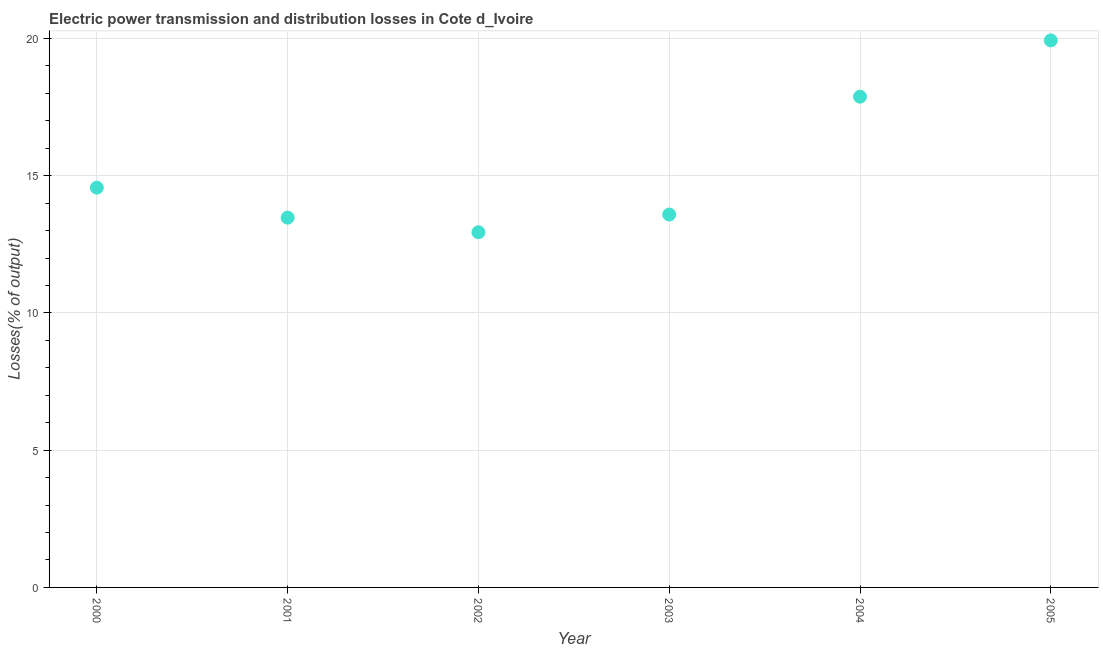What is the electric power transmission and distribution losses in 2002?
Your response must be concise. 12.94. Across all years, what is the maximum electric power transmission and distribution losses?
Your answer should be compact. 19.93. Across all years, what is the minimum electric power transmission and distribution losses?
Provide a succinct answer. 12.94. In which year was the electric power transmission and distribution losses maximum?
Your answer should be very brief. 2005. What is the sum of the electric power transmission and distribution losses?
Offer a very short reply. 92.36. What is the difference between the electric power transmission and distribution losses in 2002 and 2005?
Your response must be concise. -6.99. What is the average electric power transmission and distribution losses per year?
Provide a short and direct response. 15.39. What is the median electric power transmission and distribution losses?
Your answer should be very brief. 14.07. What is the ratio of the electric power transmission and distribution losses in 2002 to that in 2004?
Ensure brevity in your answer.  0.72. What is the difference between the highest and the second highest electric power transmission and distribution losses?
Your response must be concise. 2.05. What is the difference between the highest and the lowest electric power transmission and distribution losses?
Your response must be concise. 6.99. In how many years, is the electric power transmission and distribution losses greater than the average electric power transmission and distribution losses taken over all years?
Provide a succinct answer. 2. How many years are there in the graph?
Your answer should be very brief. 6. What is the difference between two consecutive major ticks on the Y-axis?
Keep it short and to the point. 5. Are the values on the major ticks of Y-axis written in scientific E-notation?
Your answer should be very brief. No. Does the graph contain any zero values?
Offer a terse response. No. What is the title of the graph?
Provide a short and direct response. Electric power transmission and distribution losses in Cote d_Ivoire. What is the label or title of the X-axis?
Your answer should be very brief. Year. What is the label or title of the Y-axis?
Ensure brevity in your answer.  Losses(% of output). What is the Losses(% of output) in 2000?
Offer a very short reply. 14.56. What is the Losses(% of output) in 2001?
Offer a terse response. 13.47. What is the Losses(% of output) in 2002?
Keep it short and to the point. 12.94. What is the Losses(% of output) in 2003?
Offer a terse response. 13.58. What is the Losses(% of output) in 2004?
Offer a very short reply. 17.88. What is the Losses(% of output) in 2005?
Make the answer very short. 19.93. What is the difference between the Losses(% of output) in 2000 and 2001?
Provide a short and direct response. 1.09. What is the difference between the Losses(% of output) in 2000 and 2002?
Offer a terse response. 1.62. What is the difference between the Losses(% of output) in 2000 and 2003?
Keep it short and to the point. 0.98. What is the difference between the Losses(% of output) in 2000 and 2004?
Keep it short and to the point. -3.31. What is the difference between the Losses(% of output) in 2000 and 2005?
Your response must be concise. -5.36. What is the difference between the Losses(% of output) in 2001 and 2002?
Provide a succinct answer. 0.53. What is the difference between the Losses(% of output) in 2001 and 2003?
Provide a short and direct response. -0.11. What is the difference between the Losses(% of output) in 2001 and 2004?
Ensure brevity in your answer.  -4.41. What is the difference between the Losses(% of output) in 2001 and 2005?
Provide a succinct answer. -6.46. What is the difference between the Losses(% of output) in 2002 and 2003?
Ensure brevity in your answer.  -0.64. What is the difference between the Losses(% of output) in 2002 and 2004?
Give a very brief answer. -4.94. What is the difference between the Losses(% of output) in 2002 and 2005?
Provide a succinct answer. -6.99. What is the difference between the Losses(% of output) in 2003 and 2004?
Ensure brevity in your answer.  -4.29. What is the difference between the Losses(% of output) in 2003 and 2005?
Make the answer very short. -6.34. What is the difference between the Losses(% of output) in 2004 and 2005?
Your answer should be compact. -2.05. What is the ratio of the Losses(% of output) in 2000 to that in 2001?
Ensure brevity in your answer.  1.08. What is the ratio of the Losses(% of output) in 2000 to that in 2002?
Your answer should be very brief. 1.12. What is the ratio of the Losses(% of output) in 2000 to that in 2003?
Make the answer very short. 1.07. What is the ratio of the Losses(% of output) in 2000 to that in 2004?
Ensure brevity in your answer.  0.81. What is the ratio of the Losses(% of output) in 2000 to that in 2005?
Make the answer very short. 0.73. What is the ratio of the Losses(% of output) in 2001 to that in 2002?
Keep it short and to the point. 1.04. What is the ratio of the Losses(% of output) in 2001 to that in 2004?
Your answer should be very brief. 0.75. What is the ratio of the Losses(% of output) in 2001 to that in 2005?
Make the answer very short. 0.68. What is the ratio of the Losses(% of output) in 2002 to that in 2003?
Your response must be concise. 0.95. What is the ratio of the Losses(% of output) in 2002 to that in 2004?
Give a very brief answer. 0.72. What is the ratio of the Losses(% of output) in 2002 to that in 2005?
Keep it short and to the point. 0.65. What is the ratio of the Losses(% of output) in 2003 to that in 2004?
Ensure brevity in your answer.  0.76. What is the ratio of the Losses(% of output) in 2003 to that in 2005?
Your response must be concise. 0.68. What is the ratio of the Losses(% of output) in 2004 to that in 2005?
Make the answer very short. 0.9. 